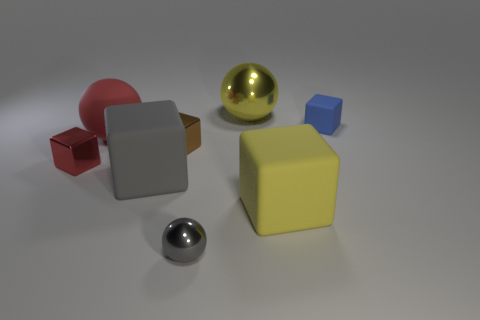What number of other things are there of the same shape as the small blue thing?
Your answer should be very brief. 4. There is a big matte thing that is right of the small metal ball; what shape is it?
Your answer should be very brief. Cube. There is a big yellow object right of the large yellow shiny object; does it have the same shape as the small metallic thing left of the gray matte object?
Give a very brief answer. Yes. Is the number of big yellow metal spheres left of the matte ball the same as the number of tiny red metallic things?
Offer a very short reply. No. Is there anything else that is the same size as the gray shiny thing?
Make the answer very short. Yes. There is a large red object that is the same shape as the gray shiny object; what material is it?
Ensure brevity in your answer.  Rubber. There is a big yellow object that is in front of the big yellow thing that is behind the blue matte thing; what is its shape?
Offer a very short reply. Cube. Does the tiny block behind the large red thing have the same material as the tiny gray ball?
Offer a very short reply. No. Are there an equal number of small blocks that are to the right of the big yellow sphere and red objects behind the rubber sphere?
Offer a terse response. No. What is the material of the cube that is the same color as the large rubber sphere?
Provide a succinct answer. Metal. 